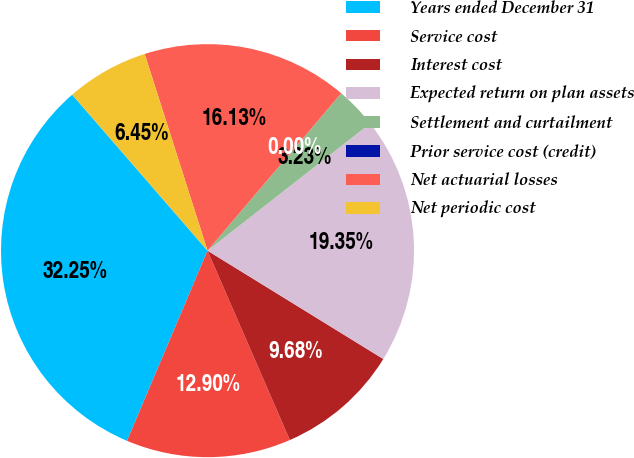Convert chart. <chart><loc_0><loc_0><loc_500><loc_500><pie_chart><fcel>Years ended December 31<fcel>Service cost<fcel>Interest cost<fcel>Expected return on plan assets<fcel>Settlement and curtailment<fcel>Prior service cost (credit)<fcel>Net actuarial losses<fcel>Net periodic cost<nl><fcel>32.25%<fcel>12.9%<fcel>9.68%<fcel>19.35%<fcel>3.23%<fcel>0.0%<fcel>16.13%<fcel>6.45%<nl></chart> 